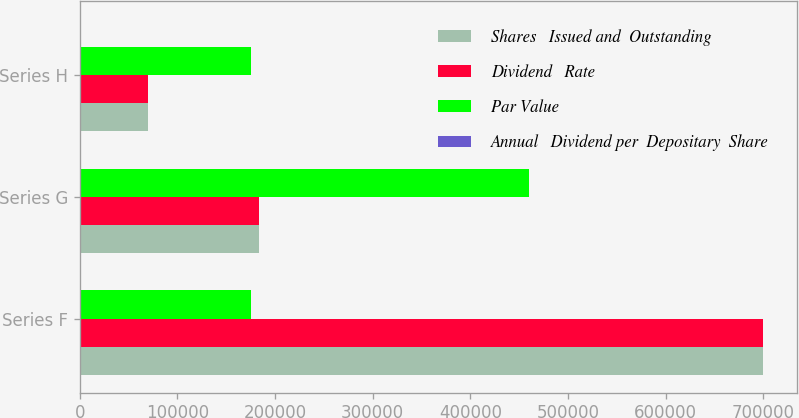Convert chart. <chart><loc_0><loc_0><loc_500><loc_500><stacked_bar_chart><ecel><fcel>Series F<fcel>Series G<fcel>Series H<nl><fcel>Shares   Issued and  Outstanding<fcel>700000<fcel>184000<fcel>70000<nl><fcel>Dividend   Rate<fcel>700000<fcel>184000<fcel>70000<nl><fcel>Par Value<fcel>175000<fcel>460000<fcel>175000<nl><fcel>Annual   Dividend per  Depositary  Share<fcel>6.65<fcel>7.75<fcel>6.9<nl></chart> 